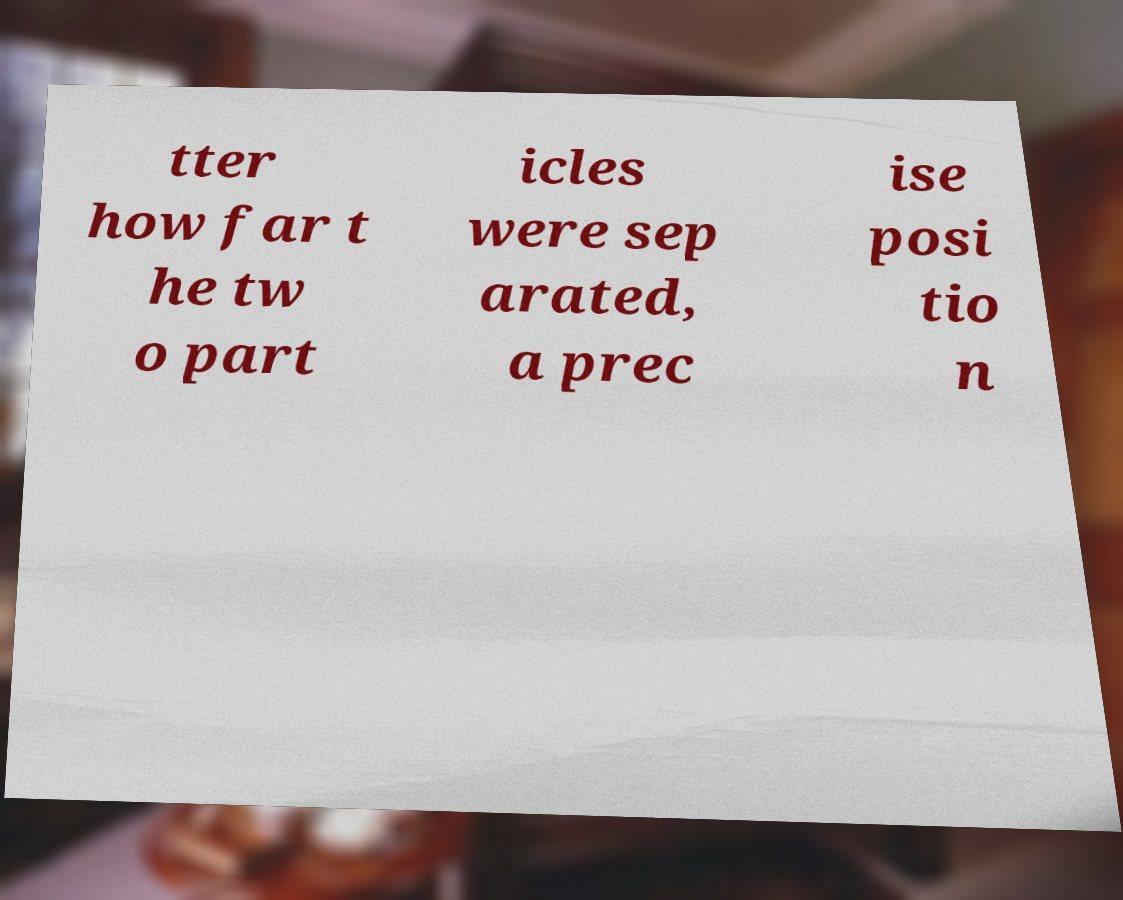Can you accurately transcribe the text from the provided image for me? tter how far t he tw o part icles were sep arated, a prec ise posi tio n 